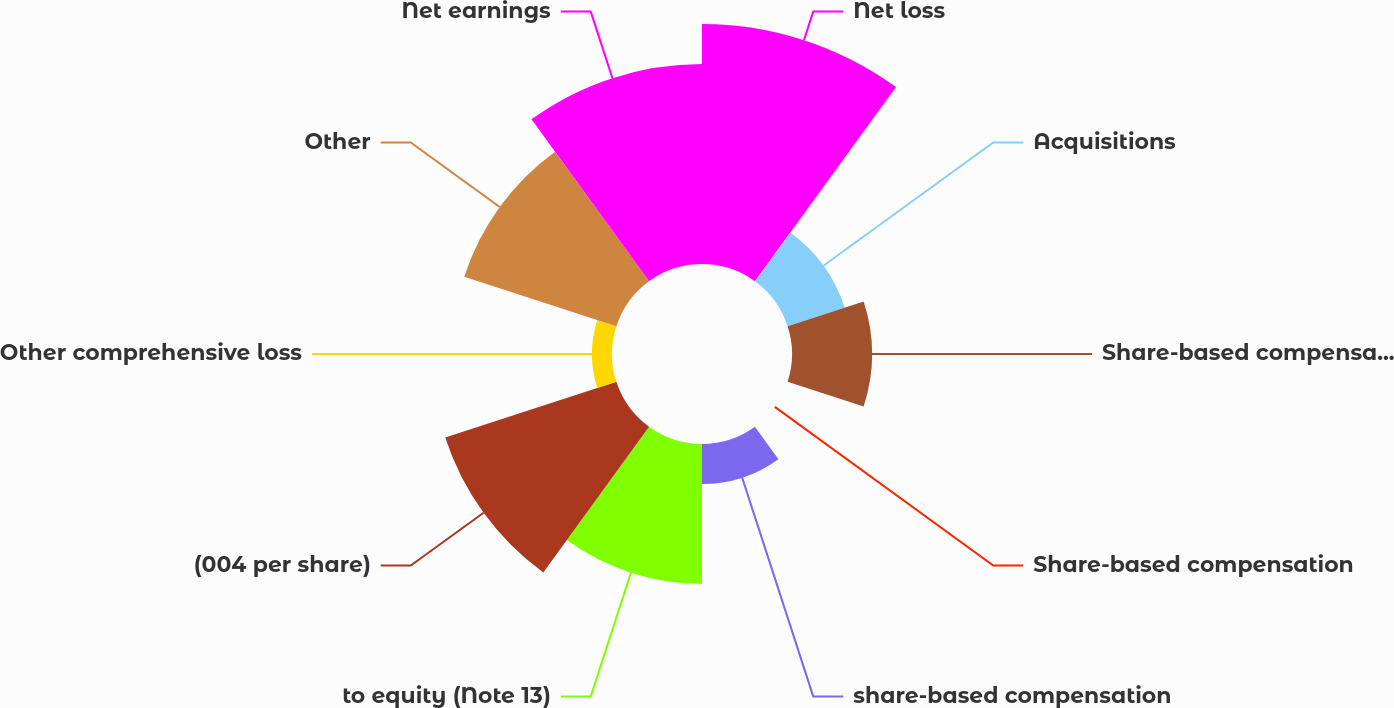Convert chart. <chart><loc_0><loc_0><loc_500><loc_500><pie_chart><fcel>Net loss<fcel>Acquisitions<fcel>Share-based compensation plans<fcel>Share-based compensation<fcel>share-based compensation<fcel>to equity (Note 13)<fcel>(004 per share)<fcel>Other comprehensive loss<fcel>Other<fcel>Net earnings<nl><fcel>21.43%<fcel>5.36%<fcel>7.14%<fcel>0.0%<fcel>3.57%<fcel>12.5%<fcel>16.07%<fcel>1.79%<fcel>14.29%<fcel>17.86%<nl></chart> 